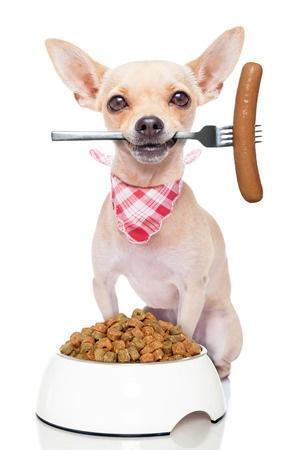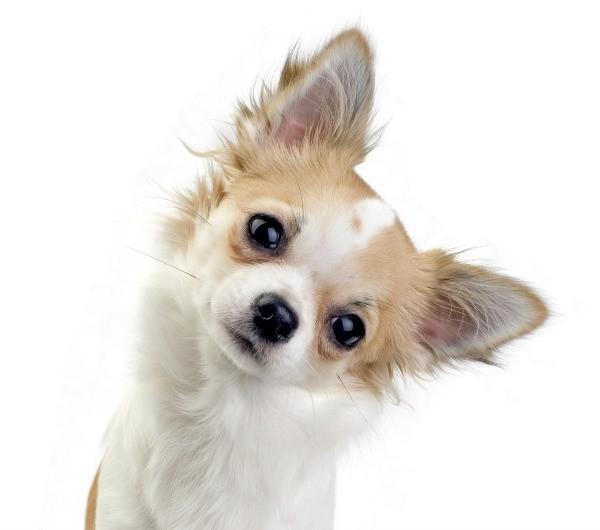The first image is the image on the left, the second image is the image on the right. Analyze the images presented: Is the assertion "The left image contains one dog that has a fork in its mouth." valid? Answer yes or no. Yes. The first image is the image on the left, the second image is the image on the right. Assess this claim about the two images: "The left image shows a chihuahua with a fork handle in its mouth sitting behind food.". Correct or not? Answer yes or no. Yes. 